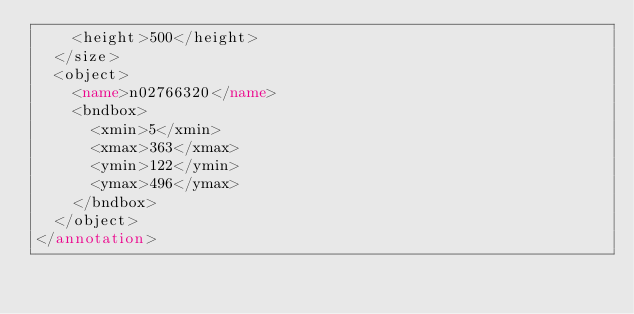Convert code to text. <code><loc_0><loc_0><loc_500><loc_500><_XML_>		<height>500</height>
	</size>
	<object>
		<name>n02766320</name>
		<bndbox>
			<xmin>5</xmin>
			<xmax>363</xmax>
			<ymin>122</ymin>
			<ymax>496</ymax>
		</bndbox>
	</object>
</annotation>
</code> 